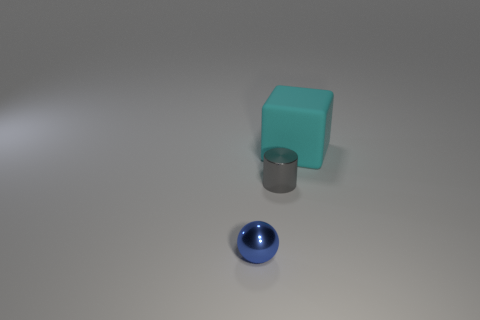Add 2 small red balls. How many objects exist? 5 Subtract all balls. How many objects are left? 2 Add 3 tiny blue objects. How many tiny blue objects exist? 4 Subtract 0 brown cubes. How many objects are left? 3 Subtract all red cylinders. Subtract all gray balls. How many cylinders are left? 1 Subtract all cyan cubes. How many green balls are left? 0 Subtract all small gray things. Subtract all gray things. How many objects are left? 1 Add 3 shiny cylinders. How many shiny cylinders are left? 4 